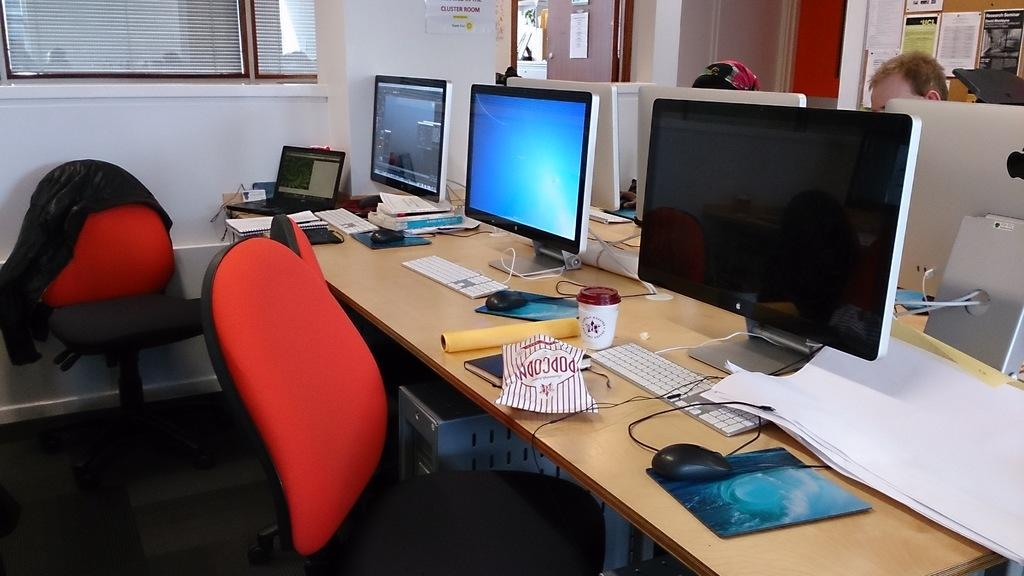<image>
Provide a brief description of the given image. A long table with 3 computer monitors and red chairs with a bag that says popcorn on the table. 